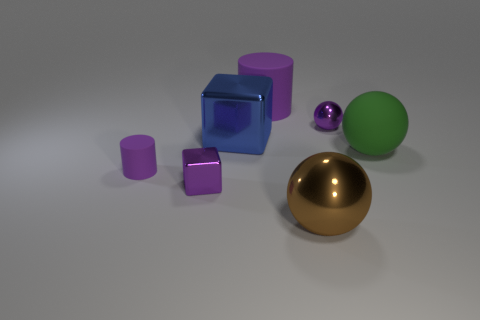Add 1 shiny things. How many objects exist? 8 Subtract all cubes. How many objects are left? 5 Add 7 small purple cylinders. How many small purple cylinders exist? 8 Subtract 0 cyan blocks. How many objects are left? 7 Subtract all purple cubes. Subtract all big green matte objects. How many objects are left? 5 Add 5 metal objects. How many metal objects are left? 9 